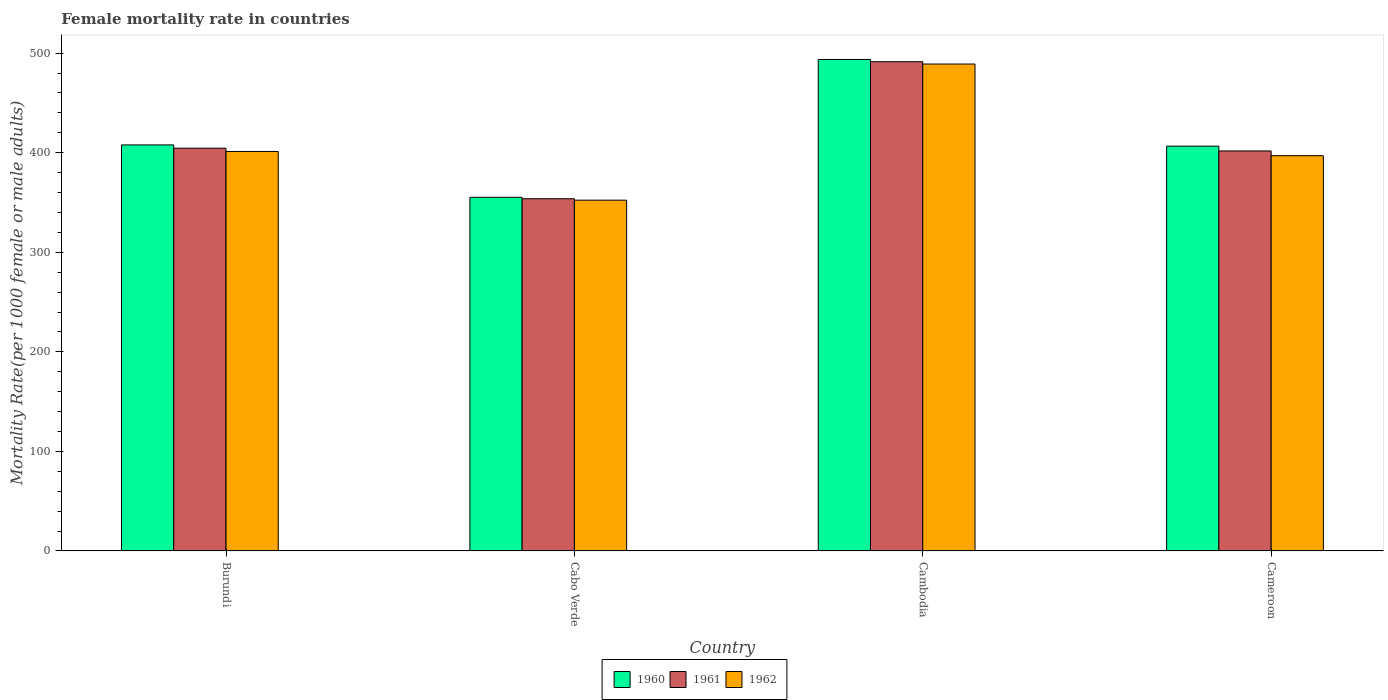Are the number of bars per tick equal to the number of legend labels?
Provide a succinct answer. Yes. Are the number of bars on each tick of the X-axis equal?
Make the answer very short. Yes. How many bars are there on the 4th tick from the left?
Provide a short and direct response. 3. How many bars are there on the 3rd tick from the right?
Provide a succinct answer. 3. What is the label of the 3rd group of bars from the left?
Your answer should be compact. Cambodia. What is the female mortality rate in 1962 in Cambodia?
Provide a succinct answer. 489.11. Across all countries, what is the maximum female mortality rate in 1960?
Provide a succinct answer. 493.7. Across all countries, what is the minimum female mortality rate in 1960?
Your response must be concise. 355.24. In which country was the female mortality rate in 1961 maximum?
Keep it short and to the point. Cambodia. In which country was the female mortality rate in 1962 minimum?
Ensure brevity in your answer.  Cabo Verde. What is the total female mortality rate in 1962 in the graph?
Provide a short and direct response. 1639.71. What is the difference between the female mortality rate in 1960 in Cabo Verde and that in Cameroon?
Your answer should be compact. -51.35. What is the difference between the female mortality rate in 1962 in Cameroon and the female mortality rate in 1961 in Burundi?
Offer a very short reply. -7.56. What is the average female mortality rate in 1962 per country?
Provide a succinct answer. 409.93. What is the difference between the female mortality rate of/in 1962 and female mortality rate of/in 1960 in Cabo Verde?
Provide a short and direct response. -2.92. What is the ratio of the female mortality rate in 1960 in Cabo Verde to that in Cambodia?
Give a very brief answer. 0.72. Is the female mortality rate in 1960 in Burundi less than that in Cabo Verde?
Your answer should be very brief. No. Is the difference between the female mortality rate in 1962 in Burundi and Cambodia greater than the difference between the female mortality rate in 1960 in Burundi and Cambodia?
Keep it short and to the point. No. What is the difference between the highest and the second highest female mortality rate in 1962?
Provide a succinct answer. 87.83. What is the difference between the highest and the lowest female mortality rate in 1960?
Make the answer very short. 138.46. In how many countries, is the female mortality rate in 1961 greater than the average female mortality rate in 1961 taken over all countries?
Make the answer very short. 1. What does the 1st bar from the left in Cameroon represents?
Your answer should be very brief. 1960. What does the 1st bar from the right in Cabo Verde represents?
Give a very brief answer. 1962. Are all the bars in the graph horizontal?
Your response must be concise. No. How many countries are there in the graph?
Your answer should be very brief. 4. Are the values on the major ticks of Y-axis written in scientific E-notation?
Your answer should be compact. No. Does the graph contain grids?
Ensure brevity in your answer.  No. How are the legend labels stacked?
Offer a very short reply. Horizontal. What is the title of the graph?
Make the answer very short. Female mortality rate in countries. What is the label or title of the Y-axis?
Give a very brief answer. Mortality Rate(per 1000 female or male adults). What is the Mortality Rate(per 1000 female or male adults) of 1960 in Burundi?
Your response must be concise. 407.84. What is the Mortality Rate(per 1000 female or male adults) of 1961 in Burundi?
Give a very brief answer. 404.56. What is the Mortality Rate(per 1000 female or male adults) of 1962 in Burundi?
Give a very brief answer. 401.28. What is the Mortality Rate(per 1000 female or male adults) of 1960 in Cabo Verde?
Make the answer very short. 355.24. What is the Mortality Rate(per 1000 female or male adults) of 1961 in Cabo Verde?
Ensure brevity in your answer.  353.78. What is the Mortality Rate(per 1000 female or male adults) of 1962 in Cabo Verde?
Provide a succinct answer. 352.33. What is the Mortality Rate(per 1000 female or male adults) of 1960 in Cambodia?
Provide a succinct answer. 493.7. What is the Mortality Rate(per 1000 female or male adults) in 1961 in Cambodia?
Offer a terse response. 491.4. What is the Mortality Rate(per 1000 female or male adults) of 1962 in Cambodia?
Make the answer very short. 489.11. What is the Mortality Rate(per 1000 female or male adults) of 1960 in Cameroon?
Offer a terse response. 406.59. What is the Mortality Rate(per 1000 female or male adults) of 1961 in Cameroon?
Your answer should be compact. 401.8. What is the Mortality Rate(per 1000 female or male adults) of 1962 in Cameroon?
Give a very brief answer. 397. Across all countries, what is the maximum Mortality Rate(per 1000 female or male adults) of 1960?
Give a very brief answer. 493.7. Across all countries, what is the maximum Mortality Rate(per 1000 female or male adults) of 1961?
Provide a succinct answer. 491.4. Across all countries, what is the maximum Mortality Rate(per 1000 female or male adults) of 1962?
Make the answer very short. 489.11. Across all countries, what is the minimum Mortality Rate(per 1000 female or male adults) of 1960?
Keep it short and to the point. 355.24. Across all countries, what is the minimum Mortality Rate(per 1000 female or male adults) of 1961?
Keep it short and to the point. 353.78. Across all countries, what is the minimum Mortality Rate(per 1000 female or male adults) of 1962?
Give a very brief answer. 352.33. What is the total Mortality Rate(per 1000 female or male adults) in 1960 in the graph?
Your response must be concise. 1663.38. What is the total Mortality Rate(per 1000 female or male adults) of 1961 in the graph?
Offer a very short reply. 1651.54. What is the total Mortality Rate(per 1000 female or male adults) of 1962 in the graph?
Your answer should be very brief. 1639.71. What is the difference between the Mortality Rate(per 1000 female or male adults) in 1960 in Burundi and that in Cabo Verde?
Ensure brevity in your answer.  52.6. What is the difference between the Mortality Rate(per 1000 female or male adults) in 1961 in Burundi and that in Cabo Verde?
Ensure brevity in your answer.  50.78. What is the difference between the Mortality Rate(per 1000 female or male adults) of 1962 in Burundi and that in Cabo Verde?
Ensure brevity in your answer.  48.95. What is the difference between the Mortality Rate(per 1000 female or male adults) of 1960 in Burundi and that in Cambodia?
Your response must be concise. -85.86. What is the difference between the Mortality Rate(per 1000 female or male adults) of 1961 in Burundi and that in Cambodia?
Provide a short and direct response. -86.84. What is the difference between the Mortality Rate(per 1000 female or male adults) in 1962 in Burundi and that in Cambodia?
Offer a very short reply. -87.83. What is the difference between the Mortality Rate(per 1000 female or male adults) in 1960 in Burundi and that in Cameroon?
Your answer should be compact. 1.25. What is the difference between the Mortality Rate(per 1000 female or male adults) in 1961 in Burundi and that in Cameroon?
Offer a very short reply. 2.77. What is the difference between the Mortality Rate(per 1000 female or male adults) in 1962 in Burundi and that in Cameroon?
Offer a terse response. 4.28. What is the difference between the Mortality Rate(per 1000 female or male adults) of 1960 in Cabo Verde and that in Cambodia?
Provide a short and direct response. -138.46. What is the difference between the Mortality Rate(per 1000 female or male adults) of 1961 in Cabo Verde and that in Cambodia?
Provide a short and direct response. -137.62. What is the difference between the Mortality Rate(per 1000 female or male adults) of 1962 in Cabo Verde and that in Cambodia?
Ensure brevity in your answer.  -136.78. What is the difference between the Mortality Rate(per 1000 female or male adults) in 1960 in Cabo Verde and that in Cameroon?
Your response must be concise. -51.35. What is the difference between the Mortality Rate(per 1000 female or male adults) in 1961 in Cabo Verde and that in Cameroon?
Offer a terse response. -48.01. What is the difference between the Mortality Rate(per 1000 female or male adults) in 1962 in Cabo Verde and that in Cameroon?
Offer a very short reply. -44.67. What is the difference between the Mortality Rate(per 1000 female or male adults) in 1960 in Cambodia and that in Cameroon?
Offer a very short reply. 87.11. What is the difference between the Mortality Rate(per 1000 female or male adults) of 1961 in Cambodia and that in Cameroon?
Offer a very short reply. 89.61. What is the difference between the Mortality Rate(per 1000 female or male adults) of 1962 in Cambodia and that in Cameroon?
Ensure brevity in your answer.  92.11. What is the difference between the Mortality Rate(per 1000 female or male adults) in 1960 in Burundi and the Mortality Rate(per 1000 female or male adults) in 1961 in Cabo Verde?
Your answer should be very brief. 54.06. What is the difference between the Mortality Rate(per 1000 female or male adults) in 1960 in Burundi and the Mortality Rate(per 1000 female or male adults) in 1962 in Cabo Verde?
Offer a very short reply. 55.52. What is the difference between the Mortality Rate(per 1000 female or male adults) in 1961 in Burundi and the Mortality Rate(per 1000 female or male adults) in 1962 in Cabo Verde?
Offer a terse response. 52.23. What is the difference between the Mortality Rate(per 1000 female or male adults) in 1960 in Burundi and the Mortality Rate(per 1000 female or male adults) in 1961 in Cambodia?
Give a very brief answer. -83.56. What is the difference between the Mortality Rate(per 1000 female or male adults) in 1960 in Burundi and the Mortality Rate(per 1000 female or male adults) in 1962 in Cambodia?
Provide a succinct answer. -81.27. What is the difference between the Mortality Rate(per 1000 female or male adults) in 1961 in Burundi and the Mortality Rate(per 1000 female or male adults) in 1962 in Cambodia?
Your answer should be compact. -84.55. What is the difference between the Mortality Rate(per 1000 female or male adults) of 1960 in Burundi and the Mortality Rate(per 1000 female or male adults) of 1961 in Cameroon?
Make the answer very short. 6.05. What is the difference between the Mortality Rate(per 1000 female or male adults) of 1960 in Burundi and the Mortality Rate(per 1000 female or male adults) of 1962 in Cameroon?
Offer a very short reply. 10.85. What is the difference between the Mortality Rate(per 1000 female or male adults) of 1961 in Burundi and the Mortality Rate(per 1000 female or male adults) of 1962 in Cameroon?
Keep it short and to the point. 7.56. What is the difference between the Mortality Rate(per 1000 female or male adults) of 1960 in Cabo Verde and the Mortality Rate(per 1000 female or male adults) of 1961 in Cambodia?
Ensure brevity in your answer.  -136.16. What is the difference between the Mortality Rate(per 1000 female or male adults) in 1960 in Cabo Verde and the Mortality Rate(per 1000 female or male adults) in 1962 in Cambodia?
Your response must be concise. -133.87. What is the difference between the Mortality Rate(per 1000 female or male adults) in 1961 in Cabo Verde and the Mortality Rate(per 1000 female or male adults) in 1962 in Cambodia?
Offer a very short reply. -135.33. What is the difference between the Mortality Rate(per 1000 female or male adults) in 1960 in Cabo Verde and the Mortality Rate(per 1000 female or male adults) in 1961 in Cameroon?
Your answer should be very brief. -46.55. What is the difference between the Mortality Rate(per 1000 female or male adults) in 1960 in Cabo Verde and the Mortality Rate(per 1000 female or male adults) in 1962 in Cameroon?
Keep it short and to the point. -41.76. What is the difference between the Mortality Rate(per 1000 female or male adults) of 1961 in Cabo Verde and the Mortality Rate(per 1000 female or male adults) of 1962 in Cameroon?
Provide a succinct answer. -43.21. What is the difference between the Mortality Rate(per 1000 female or male adults) of 1960 in Cambodia and the Mortality Rate(per 1000 female or male adults) of 1961 in Cameroon?
Give a very brief answer. 91.91. What is the difference between the Mortality Rate(per 1000 female or male adults) of 1960 in Cambodia and the Mortality Rate(per 1000 female or male adults) of 1962 in Cameroon?
Offer a very short reply. 96.7. What is the difference between the Mortality Rate(per 1000 female or male adults) of 1961 in Cambodia and the Mortality Rate(per 1000 female or male adults) of 1962 in Cameroon?
Offer a very short reply. 94.41. What is the average Mortality Rate(per 1000 female or male adults) in 1960 per country?
Offer a very short reply. 415.84. What is the average Mortality Rate(per 1000 female or male adults) of 1961 per country?
Offer a very short reply. 412.89. What is the average Mortality Rate(per 1000 female or male adults) in 1962 per country?
Your response must be concise. 409.93. What is the difference between the Mortality Rate(per 1000 female or male adults) of 1960 and Mortality Rate(per 1000 female or male adults) of 1961 in Burundi?
Offer a terse response. 3.28. What is the difference between the Mortality Rate(per 1000 female or male adults) in 1960 and Mortality Rate(per 1000 female or male adults) in 1962 in Burundi?
Make the answer very short. 6.57. What is the difference between the Mortality Rate(per 1000 female or male adults) in 1961 and Mortality Rate(per 1000 female or male adults) in 1962 in Burundi?
Offer a very short reply. 3.28. What is the difference between the Mortality Rate(per 1000 female or male adults) of 1960 and Mortality Rate(per 1000 female or male adults) of 1961 in Cabo Verde?
Offer a very short reply. 1.46. What is the difference between the Mortality Rate(per 1000 female or male adults) of 1960 and Mortality Rate(per 1000 female or male adults) of 1962 in Cabo Verde?
Offer a very short reply. 2.92. What is the difference between the Mortality Rate(per 1000 female or male adults) in 1961 and Mortality Rate(per 1000 female or male adults) in 1962 in Cabo Verde?
Keep it short and to the point. 1.46. What is the difference between the Mortality Rate(per 1000 female or male adults) in 1960 and Mortality Rate(per 1000 female or male adults) in 1961 in Cambodia?
Provide a short and direct response. 2.29. What is the difference between the Mortality Rate(per 1000 female or male adults) in 1960 and Mortality Rate(per 1000 female or male adults) in 1962 in Cambodia?
Offer a very short reply. 4.59. What is the difference between the Mortality Rate(per 1000 female or male adults) of 1961 and Mortality Rate(per 1000 female or male adults) of 1962 in Cambodia?
Your response must be concise. 2.29. What is the difference between the Mortality Rate(per 1000 female or male adults) of 1960 and Mortality Rate(per 1000 female or male adults) of 1961 in Cameroon?
Make the answer very short. 4.8. What is the difference between the Mortality Rate(per 1000 female or male adults) of 1960 and Mortality Rate(per 1000 female or male adults) of 1962 in Cameroon?
Keep it short and to the point. 9.6. What is the difference between the Mortality Rate(per 1000 female or male adults) of 1961 and Mortality Rate(per 1000 female or male adults) of 1962 in Cameroon?
Your answer should be compact. 4.8. What is the ratio of the Mortality Rate(per 1000 female or male adults) in 1960 in Burundi to that in Cabo Verde?
Provide a short and direct response. 1.15. What is the ratio of the Mortality Rate(per 1000 female or male adults) in 1961 in Burundi to that in Cabo Verde?
Ensure brevity in your answer.  1.14. What is the ratio of the Mortality Rate(per 1000 female or male adults) in 1962 in Burundi to that in Cabo Verde?
Keep it short and to the point. 1.14. What is the ratio of the Mortality Rate(per 1000 female or male adults) of 1960 in Burundi to that in Cambodia?
Offer a very short reply. 0.83. What is the ratio of the Mortality Rate(per 1000 female or male adults) in 1961 in Burundi to that in Cambodia?
Offer a very short reply. 0.82. What is the ratio of the Mortality Rate(per 1000 female or male adults) in 1962 in Burundi to that in Cambodia?
Provide a succinct answer. 0.82. What is the ratio of the Mortality Rate(per 1000 female or male adults) in 1960 in Burundi to that in Cameroon?
Keep it short and to the point. 1. What is the ratio of the Mortality Rate(per 1000 female or male adults) in 1961 in Burundi to that in Cameroon?
Your answer should be very brief. 1.01. What is the ratio of the Mortality Rate(per 1000 female or male adults) in 1962 in Burundi to that in Cameroon?
Provide a succinct answer. 1.01. What is the ratio of the Mortality Rate(per 1000 female or male adults) in 1960 in Cabo Verde to that in Cambodia?
Keep it short and to the point. 0.72. What is the ratio of the Mortality Rate(per 1000 female or male adults) in 1961 in Cabo Verde to that in Cambodia?
Offer a terse response. 0.72. What is the ratio of the Mortality Rate(per 1000 female or male adults) of 1962 in Cabo Verde to that in Cambodia?
Your answer should be compact. 0.72. What is the ratio of the Mortality Rate(per 1000 female or male adults) in 1960 in Cabo Verde to that in Cameroon?
Your response must be concise. 0.87. What is the ratio of the Mortality Rate(per 1000 female or male adults) of 1961 in Cabo Verde to that in Cameroon?
Offer a very short reply. 0.88. What is the ratio of the Mortality Rate(per 1000 female or male adults) in 1962 in Cabo Verde to that in Cameroon?
Offer a very short reply. 0.89. What is the ratio of the Mortality Rate(per 1000 female or male adults) of 1960 in Cambodia to that in Cameroon?
Offer a terse response. 1.21. What is the ratio of the Mortality Rate(per 1000 female or male adults) of 1961 in Cambodia to that in Cameroon?
Keep it short and to the point. 1.22. What is the ratio of the Mortality Rate(per 1000 female or male adults) in 1962 in Cambodia to that in Cameroon?
Offer a very short reply. 1.23. What is the difference between the highest and the second highest Mortality Rate(per 1000 female or male adults) in 1960?
Give a very brief answer. 85.86. What is the difference between the highest and the second highest Mortality Rate(per 1000 female or male adults) in 1961?
Ensure brevity in your answer.  86.84. What is the difference between the highest and the second highest Mortality Rate(per 1000 female or male adults) in 1962?
Your answer should be compact. 87.83. What is the difference between the highest and the lowest Mortality Rate(per 1000 female or male adults) of 1960?
Your answer should be very brief. 138.46. What is the difference between the highest and the lowest Mortality Rate(per 1000 female or male adults) in 1961?
Your response must be concise. 137.62. What is the difference between the highest and the lowest Mortality Rate(per 1000 female or male adults) in 1962?
Your answer should be very brief. 136.78. 